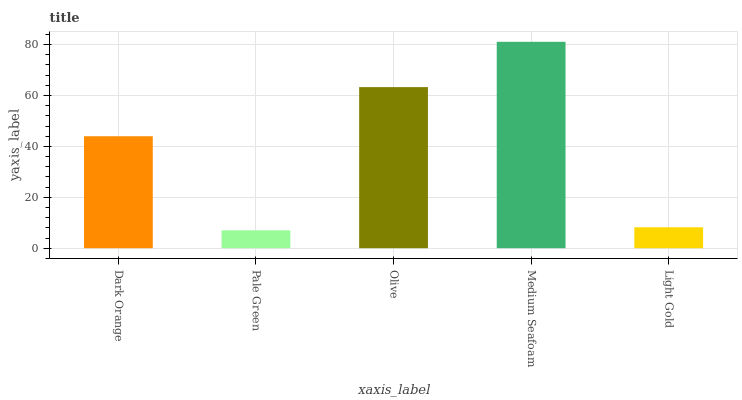Is Pale Green the minimum?
Answer yes or no. Yes. Is Medium Seafoam the maximum?
Answer yes or no. Yes. Is Olive the minimum?
Answer yes or no. No. Is Olive the maximum?
Answer yes or no. No. Is Olive greater than Pale Green?
Answer yes or no. Yes. Is Pale Green less than Olive?
Answer yes or no. Yes. Is Pale Green greater than Olive?
Answer yes or no. No. Is Olive less than Pale Green?
Answer yes or no. No. Is Dark Orange the high median?
Answer yes or no. Yes. Is Dark Orange the low median?
Answer yes or no. Yes. Is Olive the high median?
Answer yes or no. No. Is Medium Seafoam the low median?
Answer yes or no. No. 